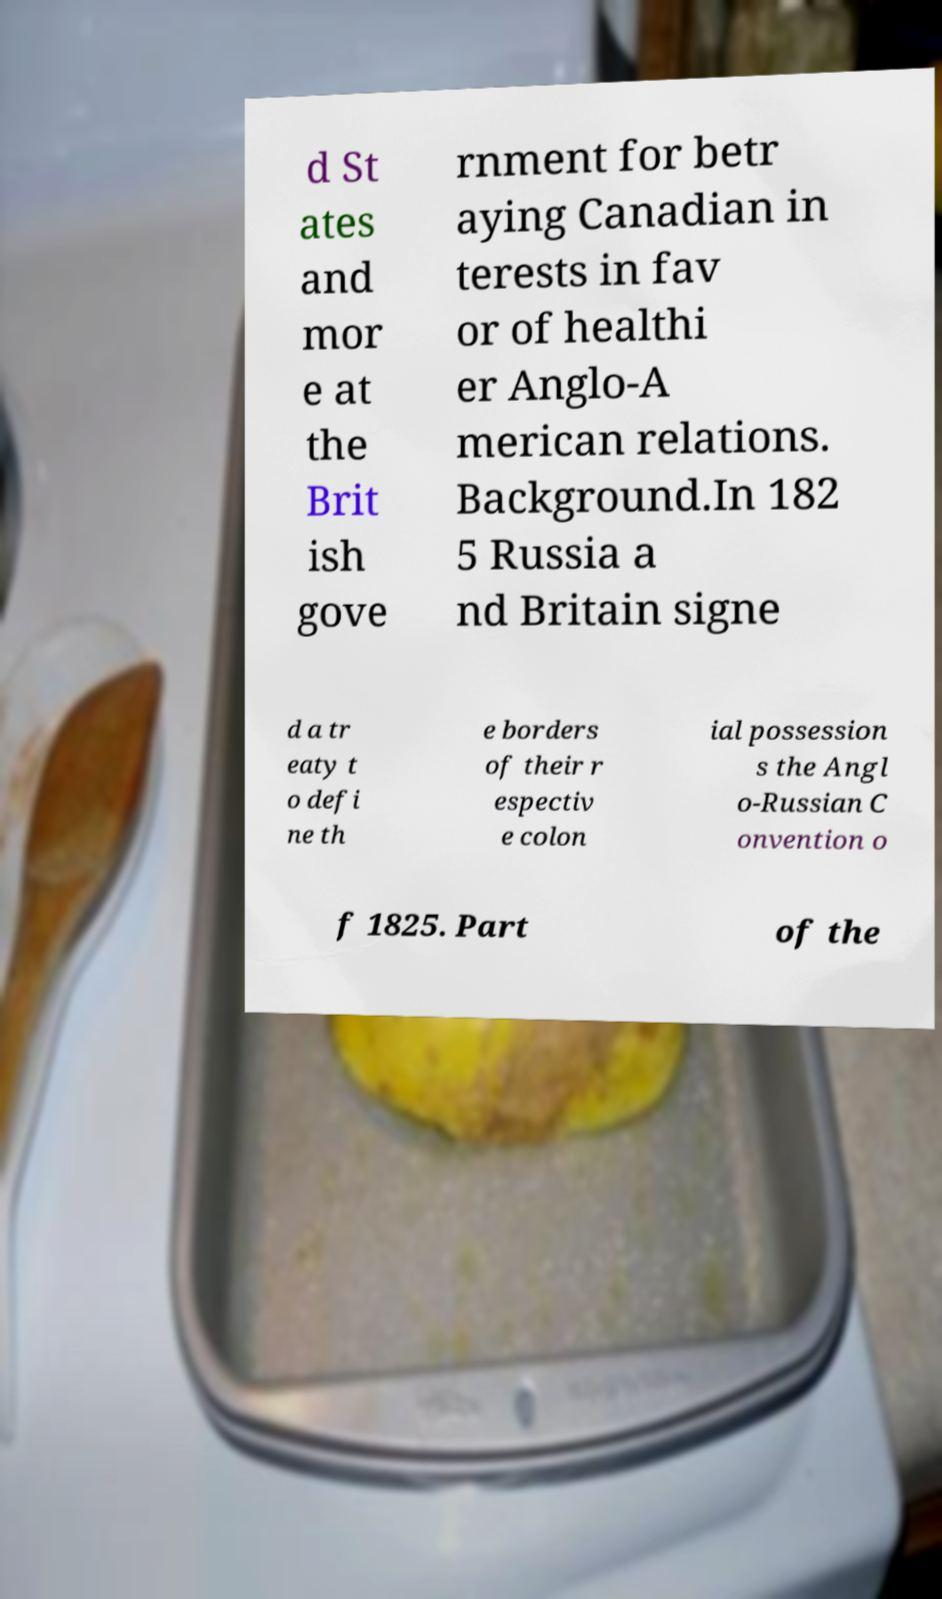I need the written content from this picture converted into text. Can you do that? d St ates and mor e at the Brit ish gove rnment for betr aying Canadian in terests in fav or of healthi er Anglo-A merican relations. Background.In 182 5 Russia a nd Britain signe d a tr eaty t o defi ne th e borders of their r espectiv e colon ial possession s the Angl o-Russian C onvention o f 1825. Part of the 